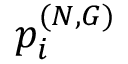Convert formula to latex. <formula><loc_0><loc_0><loc_500><loc_500>p _ { i } ^ { ( N , G ) }</formula> 